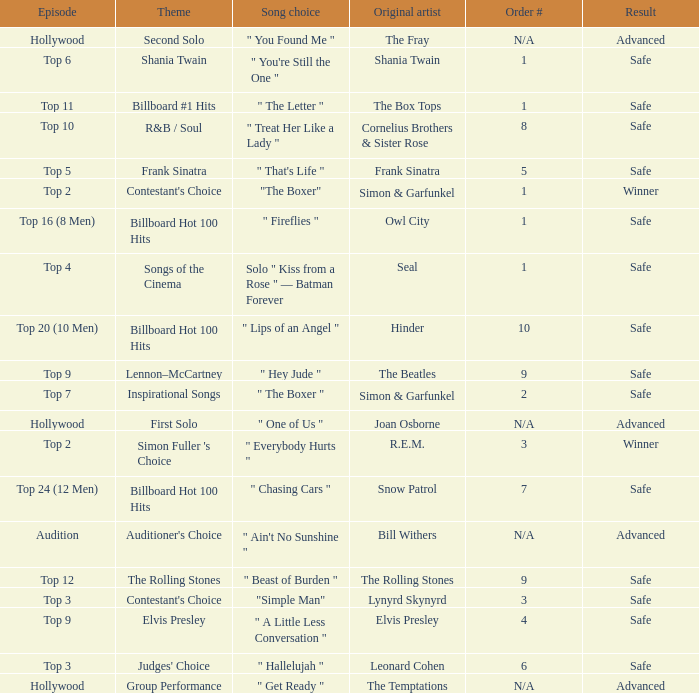In which episode is the order number 10? Top 20 (10 Men). 